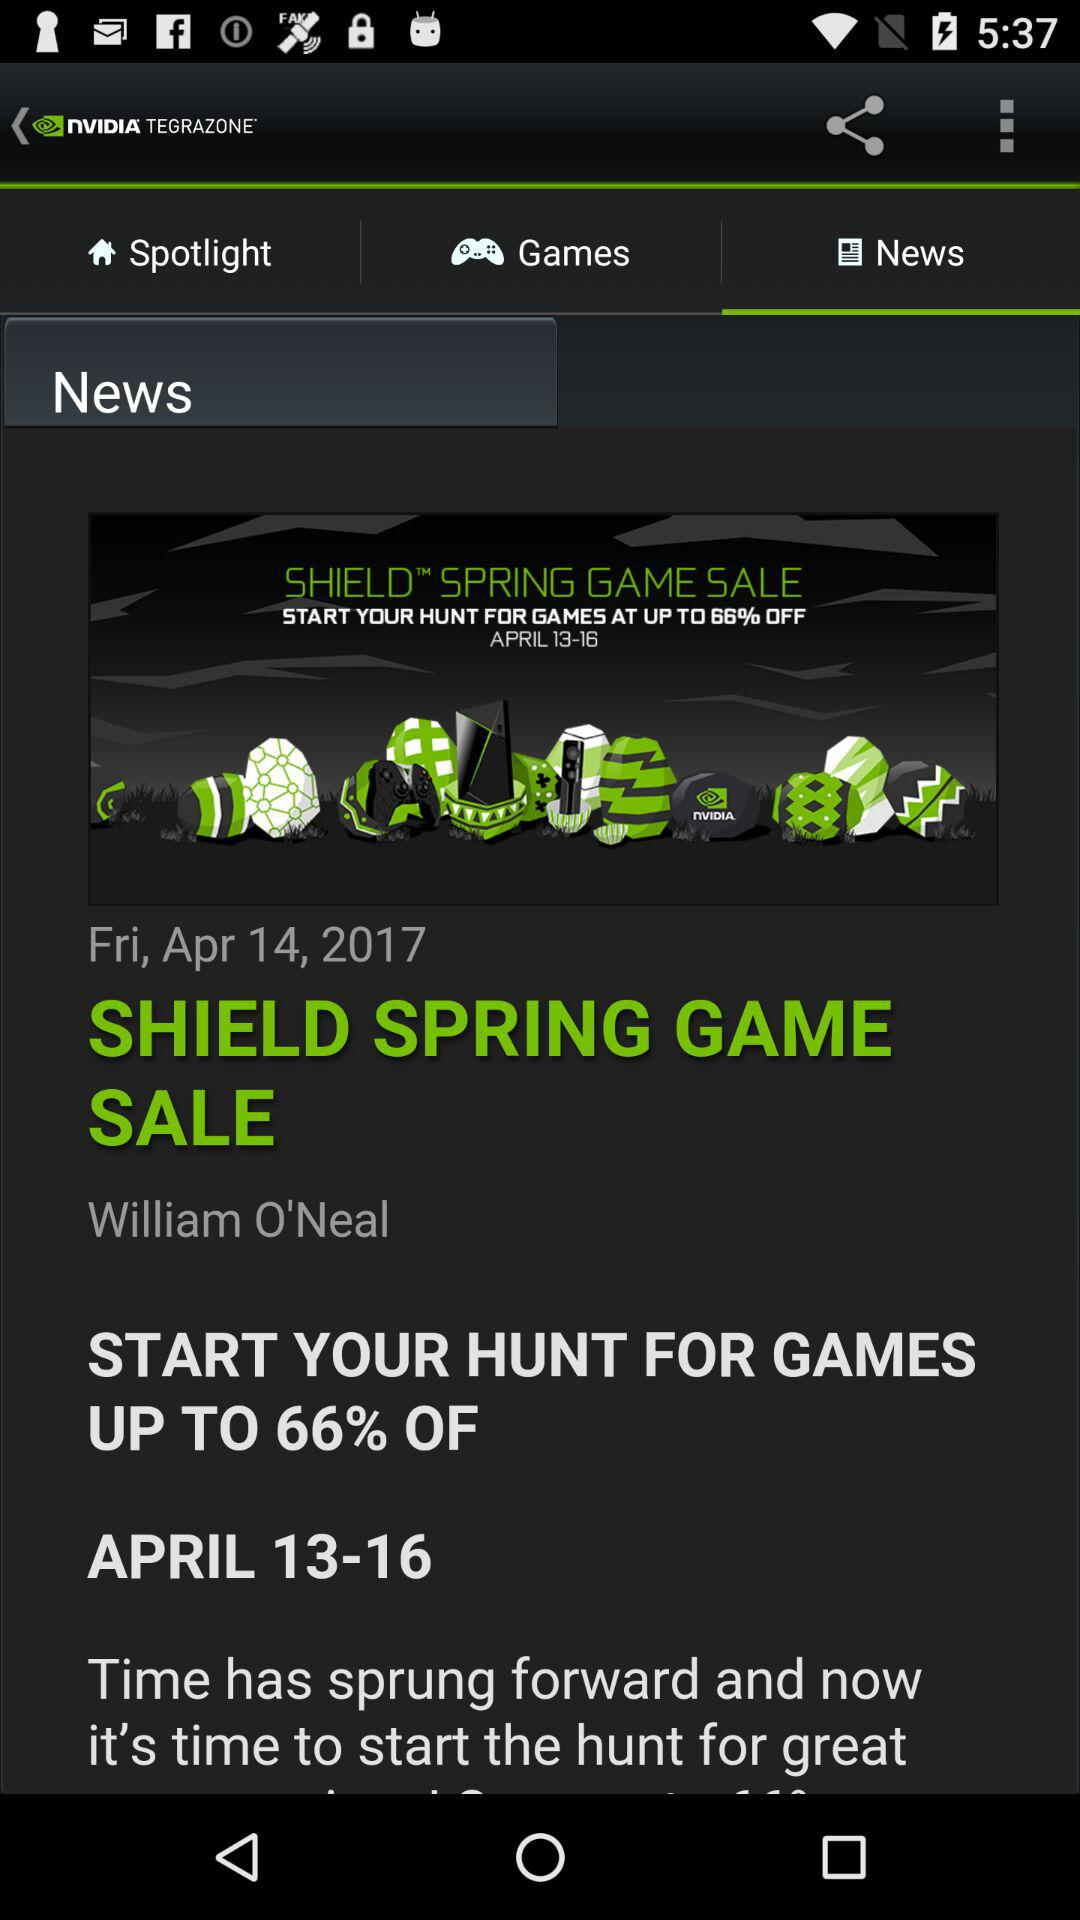What is the publication date? The publication date is Friday, April 14, 2017. 